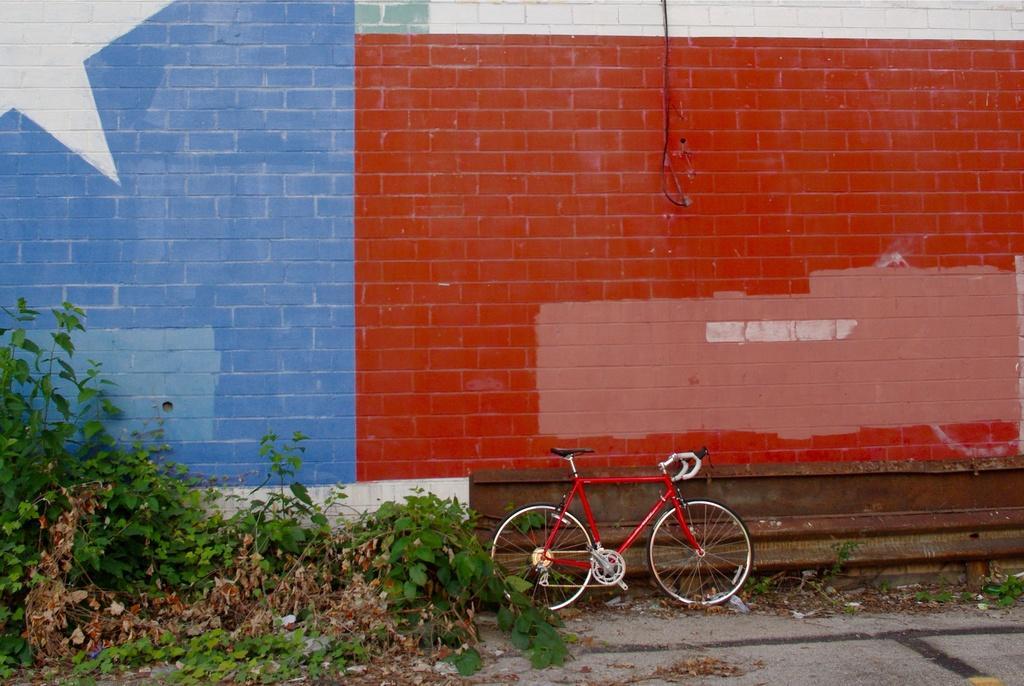Please provide a concise description of this image. In this image I can see a bicycle beside a wall. Here I can see plants, Here I can see a brick wall which is blue and red in color. I can also see some object on the wall. 